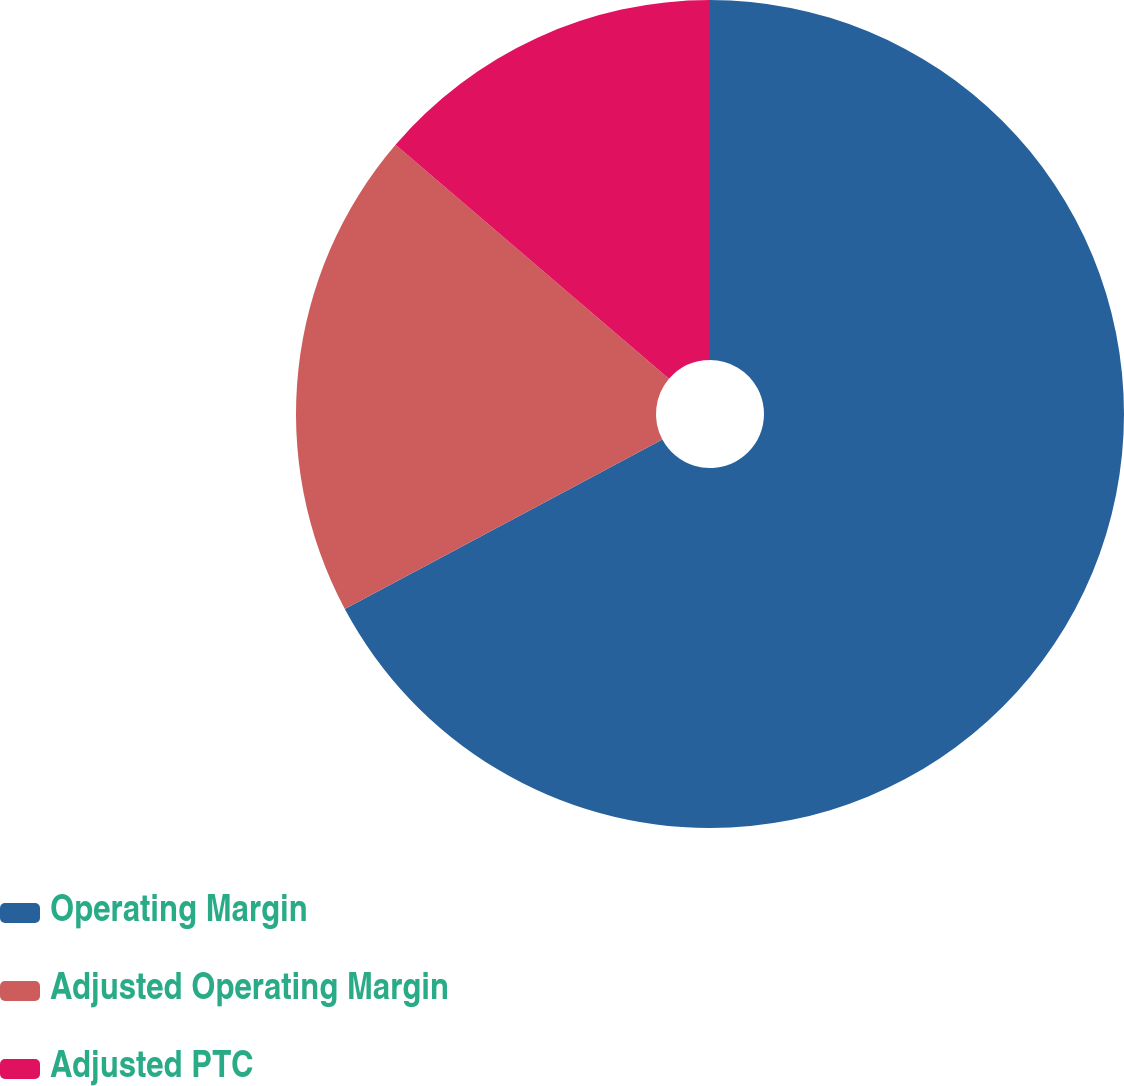Convert chart. <chart><loc_0><loc_0><loc_500><loc_500><pie_chart><fcel>Operating Margin<fcel>Adjusted Operating Margin<fcel>Adjusted PTC<nl><fcel>67.2%<fcel>19.08%<fcel>13.73%<nl></chart> 